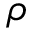<formula> <loc_0><loc_0><loc_500><loc_500>\rho</formula> 